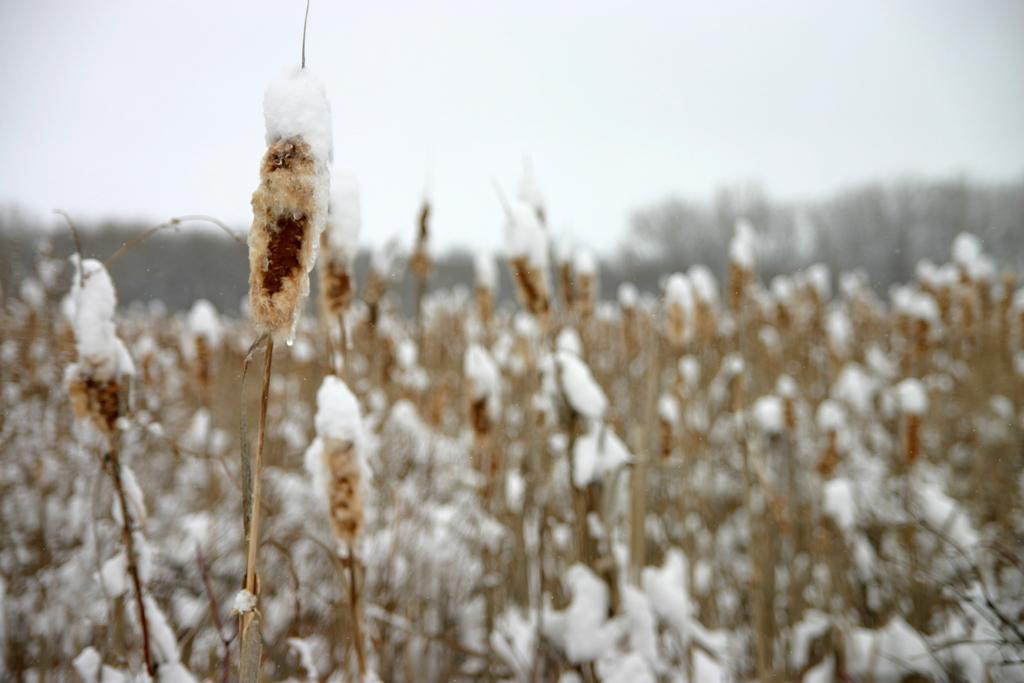What color are the plants in the image? The plants in the image are brown in color. What is covering the plants in the image? Snow is present on the plants in the image. What is the color of the sky in the image? The sky is white in color in the image. Can you see any bones sticking out of the plants in the image? No, there are no bones visible in the image. 